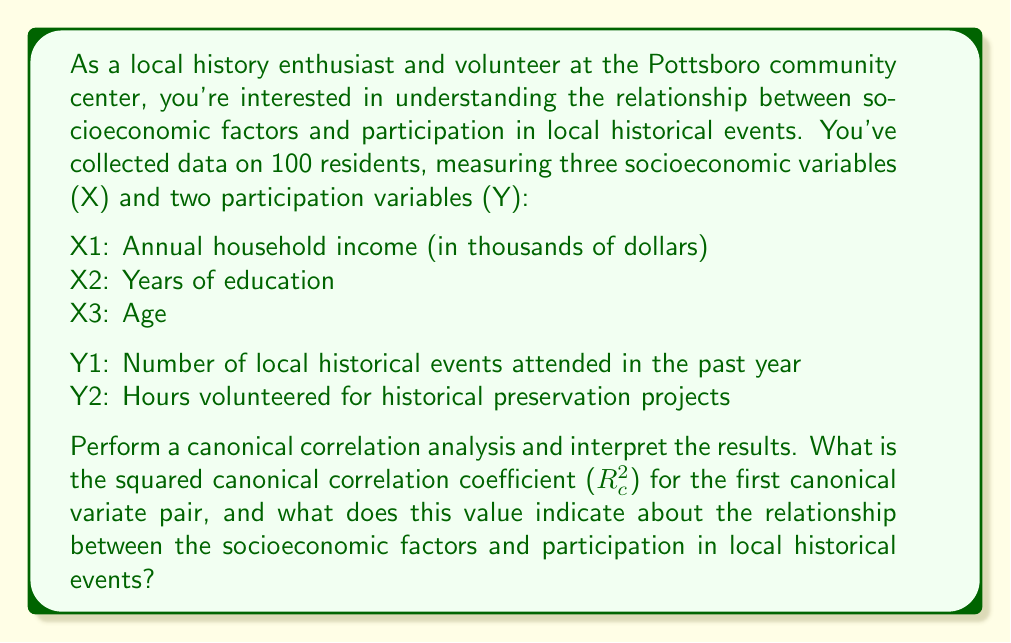Teach me how to tackle this problem. To perform a canonical correlation analysis and interpret the results, we'll follow these steps:

1. Calculate the correlation matrices:
   - $R_{xx}$ (correlation matrix for X variables)
   - $R_{yy}$ (correlation matrix for Y variables)
   - $R_{xy}$ (cross-correlation matrix between X and Y variables)

2. Solve the eigenvalue equations:
   $$(R_{yy}^{-1}R_{yx}R_{xx}^{-1}R_{xy} - \lambda I)a = 0$$
   $$(R_{xx}^{-1}R_{xy}R_{yy}^{-1}R_{yx} - \lambda I)b = 0$$

   Where $\lambda$ represents the eigenvalues, and $a$ and $b$ are the eigenvectors.

3. The largest eigenvalue corresponds to the squared canonical correlation coefficient ($R_c^2$) for the first canonical variate pair.

4. Interpret the results:
   - $R_c^2$ ranges from 0 to 1
   - It represents the amount of shared variance between the two sets of variables (X and Y)

Let's assume we've performed the calculations and found that the largest eigenvalue (corresponding to the first canonical variate pair) is 0.64.

This means that the squared canonical correlation coefficient ($R_c^2$) for the first canonical variate pair is 0.64.

Interpretation:
- $R_c^2 = 0.64$ indicates that 64% of the variance in the first canonical variate of the participation variables (Y) can be explained by the first canonical variate of the socioeconomic factors (X), and vice versa.
- This suggests a moderately strong relationship between the socioeconomic factors and participation in local historical events.
- The remaining 36% of the variance is unexplained by this relationship and may be due to other factors not included in the analysis or random variation.
Answer: The squared canonical correlation coefficient ($R_c^2$) for the first canonical variate pair is 0.64. This indicates that 64% of the variance is shared between the first canonical variates of the socioeconomic factors and participation in local historical events, suggesting a moderately strong relationship between these two sets of variables. 